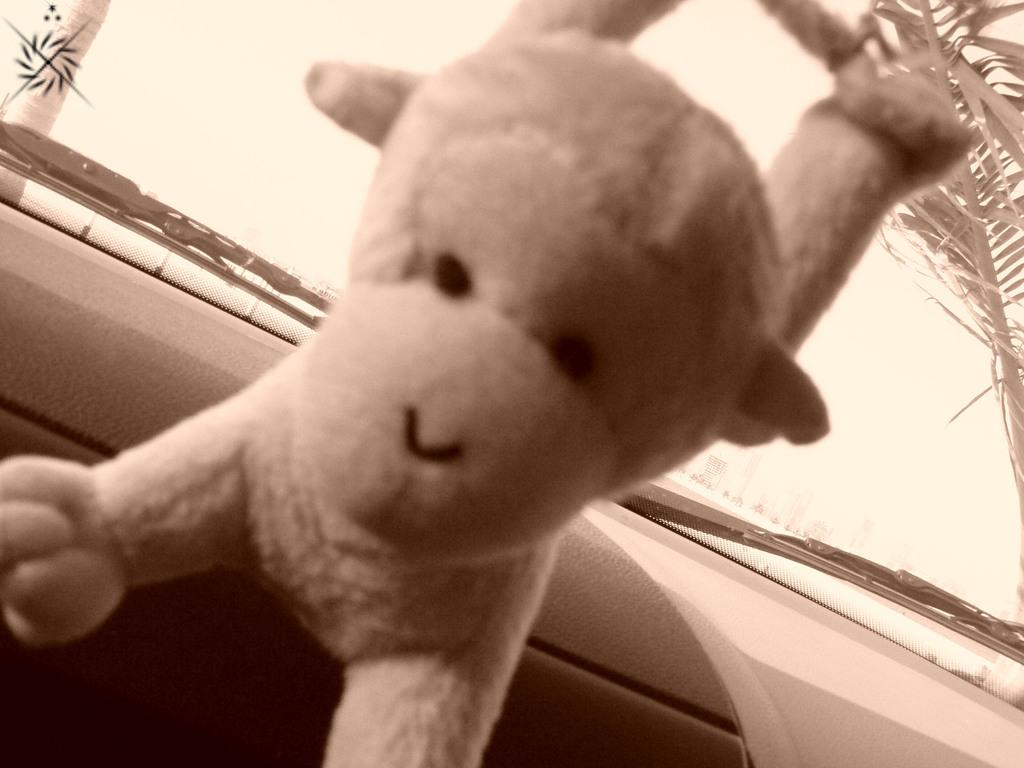What is the setting of the image? The image shows the inside view of a car. What object can be seen on the dashboard? There is a toy placed on the dashboard. What feature is visible on the windshield? Glass wipers are visible in the image. What can be seen through the glass? A tree is visible through the glass. What type of berry is being eaten by the bear in the image? There are no berries or bears present in the image; it shows the inside view of a car. 